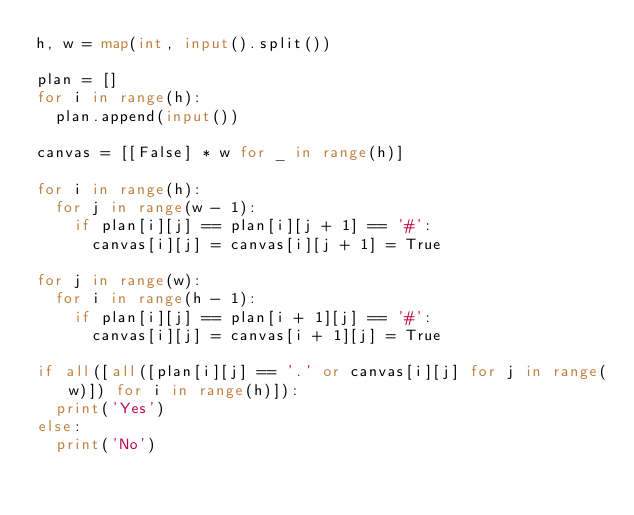<code> <loc_0><loc_0><loc_500><loc_500><_Python_>h, w = map(int, input().split())

plan = []
for i in range(h):
  plan.append(input())

canvas = [[False] * w for _ in range(h)]

for i in range(h):
  for j in range(w - 1):
    if plan[i][j] == plan[i][j + 1] == '#':
      canvas[i][j] = canvas[i][j + 1] = True

for j in range(w):
  for i in range(h - 1):
    if plan[i][j] == plan[i + 1][j] == '#':
      canvas[i][j] = canvas[i + 1][j] = True

if all([all([plan[i][j] == '.' or canvas[i][j] for j in range(w)]) for i in range(h)]):
  print('Yes')
else:
  print('No')
</code> 